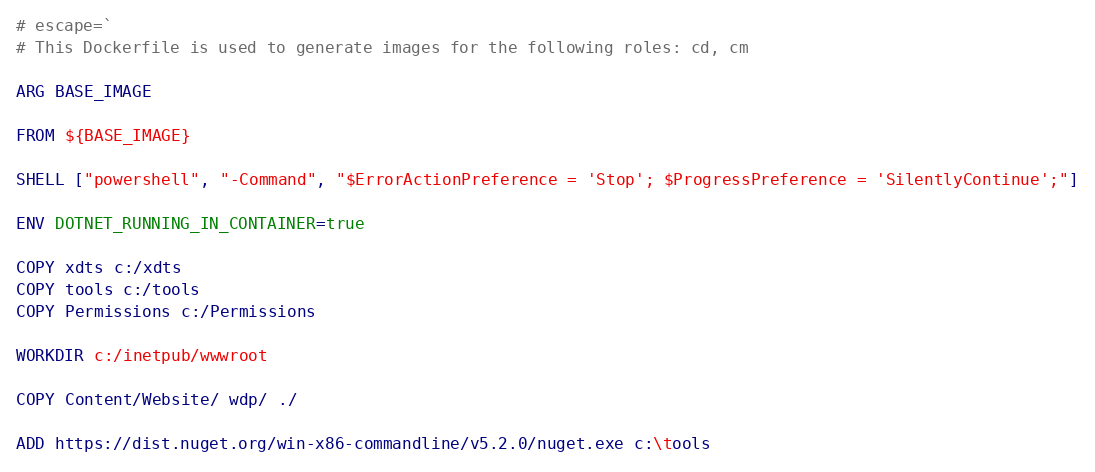<code> <loc_0><loc_0><loc_500><loc_500><_Dockerfile_># escape=`
# This Dockerfile is used to generate images for the following roles: cd, cm

ARG BASE_IMAGE

FROM ${BASE_IMAGE}

SHELL ["powershell", "-Command", "$ErrorActionPreference = 'Stop'; $ProgressPreference = 'SilentlyContinue';"]

ENV DOTNET_RUNNING_IN_CONTAINER=true

COPY xdts c:/xdts
COPY tools c:/tools
COPY Permissions c:/Permissions

WORKDIR c:/inetpub/wwwroot

COPY Content/Website/ wdp/ ./

ADD https://dist.nuget.org/win-x86-commandline/v5.2.0/nuget.exe c:\tools
</code> 